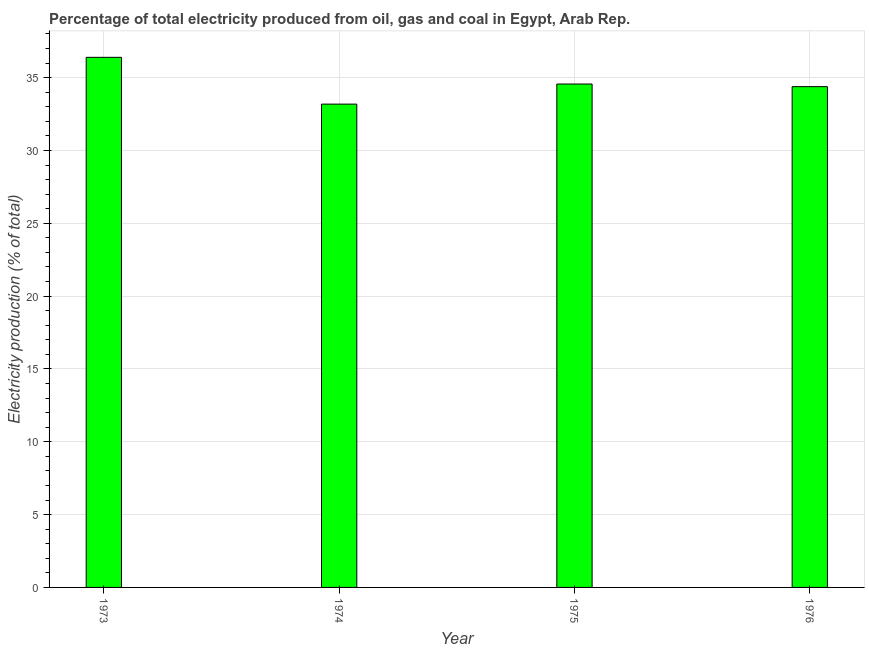Does the graph contain any zero values?
Your answer should be compact. No. What is the title of the graph?
Ensure brevity in your answer.  Percentage of total electricity produced from oil, gas and coal in Egypt, Arab Rep. What is the label or title of the X-axis?
Offer a terse response. Year. What is the label or title of the Y-axis?
Give a very brief answer. Electricity production (% of total). What is the electricity production in 1973?
Give a very brief answer. 36.39. Across all years, what is the maximum electricity production?
Provide a succinct answer. 36.39. Across all years, what is the minimum electricity production?
Make the answer very short. 33.18. In which year was the electricity production maximum?
Ensure brevity in your answer.  1973. In which year was the electricity production minimum?
Your answer should be compact. 1974. What is the sum of the electricity production?
Give a very brief answer. 138.51. What is the difference between the electricity production in 1973 and 1975?
Your answer should be compact. 1.83. What is the average electricity production per year?
Keep it short and to the point. 34.63. What is the median electricity production?
Offer a very short reply. 34.47. In how many years, is the electricity production greater than 10 %?
Provide a short and direct response. 4. Is the electricity production in 1973 less than that in 1976?
Your answer should be very brief. No. Is the difference between the electricity production in 1973 and 1974 greater than the difference between any two years?
Ensure brevity in your answer.  Yes. What is the difference between the highest and the second highest electricity production?
Your answer should be compact. 1.83. What is the difference between the highest and the lowest electricity production?
Your answer should be compact. 3.21. In how many years, is the electricity production greater than the average electricity production taken over all years?
Offer a very short reply. 1. How many bars are there?
Give a very brief answer. 4. What is the difference between two consecutive major ticks on the Y-axis?
Your answer should be compact. 5. Are the values on the major ticks of Y-axis written in scientific E-notation?
Offer a terse response. No. What is the Electricity production (% of total) in 1973?
Provide a short and direct response. 36.39. What is the Electricity production (% of total) in 1974?
Make the answer very short. 33.18. What is the Electricity production (% of total) in 1975?
Ensure brevity in your answer.  34.56. What is the Electricity production (% of total) in 1976?
Make the answer very short. 34.38. What is the difference between the Electricity production (% of total) in 1973 and 1974?
Make the answer very short. 3.21. What is the difference between the Electricity production (% of total) in 1973 and 1975?
Give a very brief answer. 1.83. What is the difference between the Electricity production (% of total) in 1973 and 1976?
Your answer should be compact. 2.01. What is the difference between the Electricity production (% of total) in 1974 and 1975?
Offer a terse response. -1.38. What is the difference between the Electricity production (% of total) in 1974 and 1976?
Your answer should be compact. -1.2. What is the difference between the Electricity production (% of total) in 1975 and 1976?
Ensure brevity in your answer.  0.18. What is the ratio of the Electricity production (% of total) in 1973 to that in 1974?
Provide a short and direct response. 1.1. What is the ratio of the Electricity production (% of total) in 1973 to that in 1975?
Your answer should be compact. 1.05. What is the ratio of the Electricity production (% of total) in 1973 to that in 1976?
Offer a very short reply. 1.06. What is the ratio of the Electricity production (% of total) in 1974 to that in 1975?
Offer a very short reply. 0.96. What is the ratio of the Electricity production (% of total) in 1975 to that in 1976?
Your response must be concise. 1. 